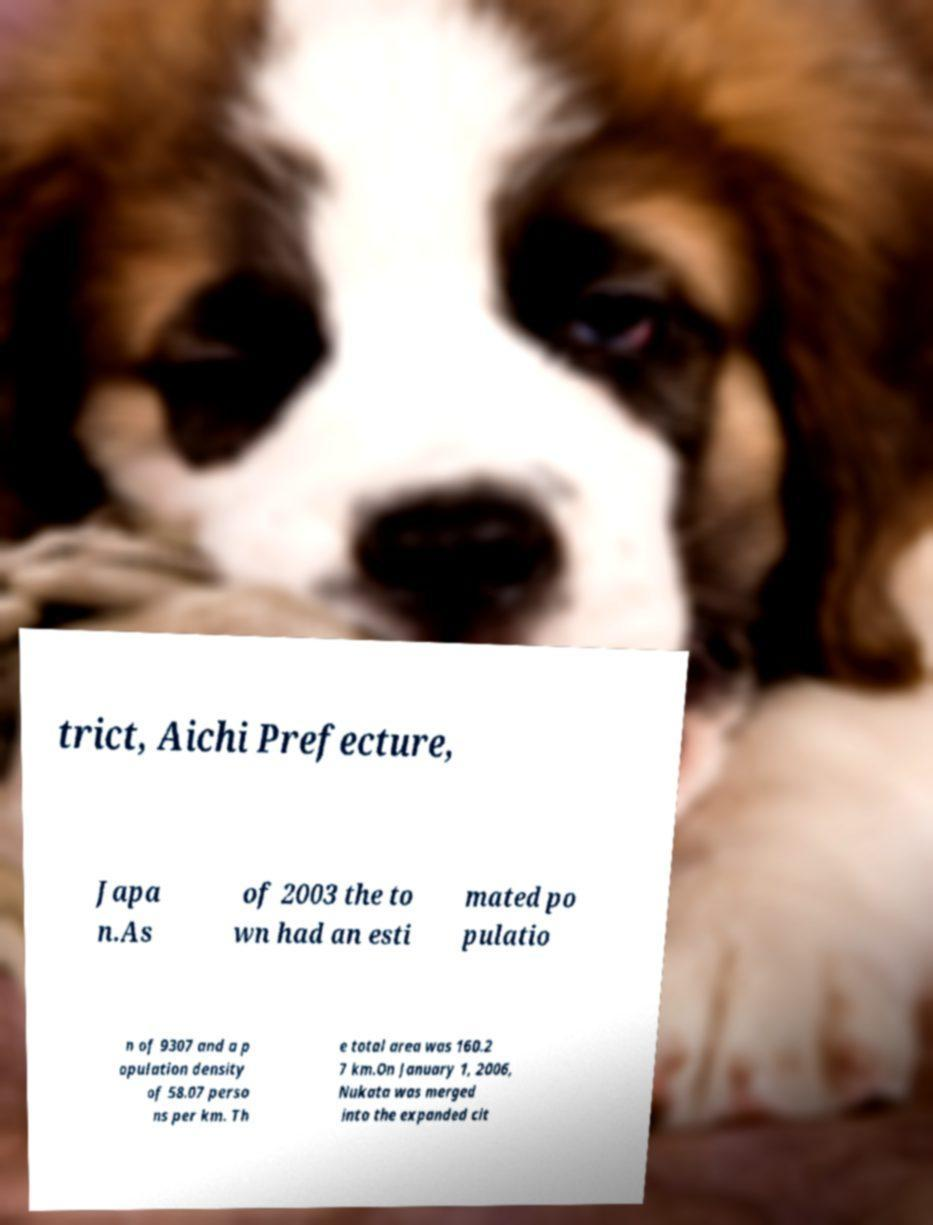Please identify and transcribe the text found in this image. trict, Aichi Prefecture, Japa n.As of 2003 the to wn had an esti mated po pulatio n of 9307 and a p opulation density of 58.07 perso ns per km. Th e total area was 160.2 7 km.On January 1, 2006, Nukata was merged into the expanded cit 